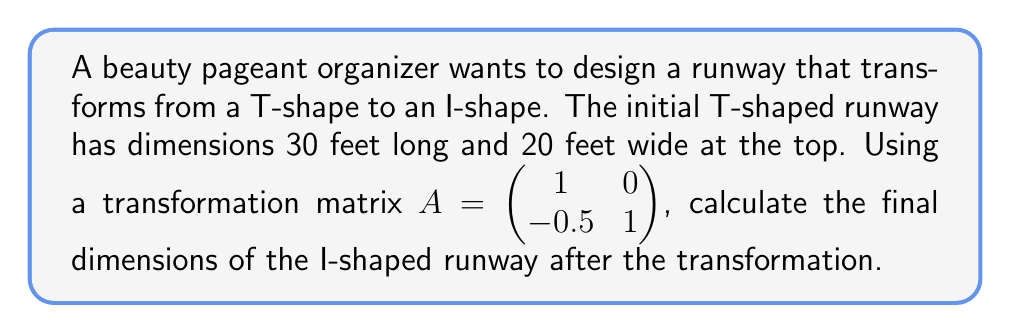Help me with this question. Let's approach this step-by-step:

1) First, we need to represent the T-shape as vectors. We can use three vectors:
   $v_1 = \begin{pmatrix} 30 \\ 0 \end{pmatrix}$ (length of runway)
   $v_2 = \begin{pmatrix} 0 \\ 10 \end{pmatrix}$ (half-width of top)
   $v_3 = \begin{pmatrix} 0 \\ -10 \end{pmatrix}$ (other half-width of top)

2) To transform these vectors, we multiply each by matrix A:

   $Av_1 = \begin{pmatrix} 1 & 0 \\ -0.5 & 1 \end{pmatrix} \begin{pmatrix} 30 \\ 0 \end{pmatrix} = \begin{pmatrix} 30 \\ -15 \end{pmatrix}$

   $Av_2 = \begin{pmatrix} 1 & 0 \\ -0.5 & 1 \end{pmatrix} \begin{pmatrix} 0 \\ 10 \end{pmatrix} = \begin{pmatrix} 0 \\ 10 \end{pmatrix}$

   $Av_3 = \begin{pmatrix} 1 & 0 \\ -0.5 & 1 \end{pmatrix} \begin{pmatrix} 0 \\ -10 \end{pmatrix} = \begin{pmatrix} 0 \\ -10 \end{pmatrix}$

3) The new runway shape is defined by these transformed vectors:
   - The length is still 30 feet (x-component of $Av_1$)
   - The width at the start is still 20 feet (y-components of $Av_2$ and $Av_3$)
   - The width at the end is 0 (y-component of $Av_1$ cancels out $Av_2$ and $Av_3$)

4) Therefore, the I-shaped runway has dimensions 30 feet long, 20 feet wide at the start, and tapers to 0 feet wide at the end.
Answer: 30 feet long, 20 feet wide at start, 0 feet wide at end 